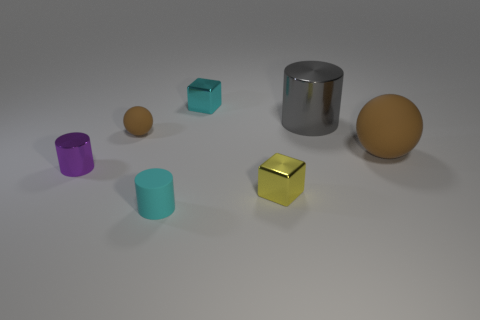What shape is the object that is on the left side of the big matte object and on the right side of the tiny yellow shiny cube? cylinder 